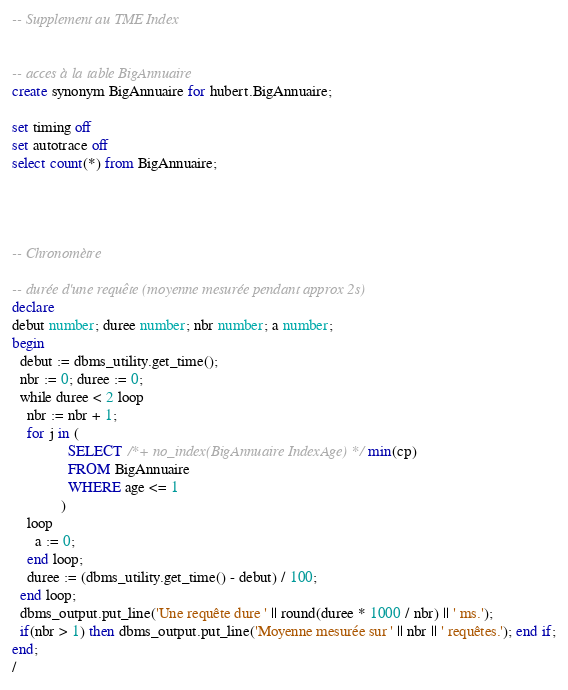<code> <loc_0><loc_0><loc_500><loc_500><_SQL_>
-- Supplement au TME Index


-- acces à la table BigAnnuaire
create synonym BigAnnuaire for hubert.BigAnnuaire;

set timing off
set autotrace off
select count(*) from BigAnnuaire;




-- Chronomètre

-- durée d'une requête (moyenne mesurée pendant approx 2s)
declare
debut number; duree number; nbr number; a number;
begin
  debut := dbms_utility.get_time();
  nbr := 0; duree := 0;
  while duree < 2 loop
    nbr := nbr + 1;
    for j in (
               SELECT /*+ no_index(BigAnnuaire IndexAge)*/ min(cp)
               FROM BigAnnuaire 
               WHERE age <= 1
             )
    loop
      a := 0;
    end loop;
    duree := (dbms_utility.get_time() - debut) / 100;
  end loop;
  dbms_output.put_line('Une requête dure ' || round(duree * 1000 / nbr) || ' ms.');
  if(nbr > 1) then dbms_output.put_line('Moyenne mesurée sur ' || nbr || ' requêtes.'); end if;
end;
/


</code> 